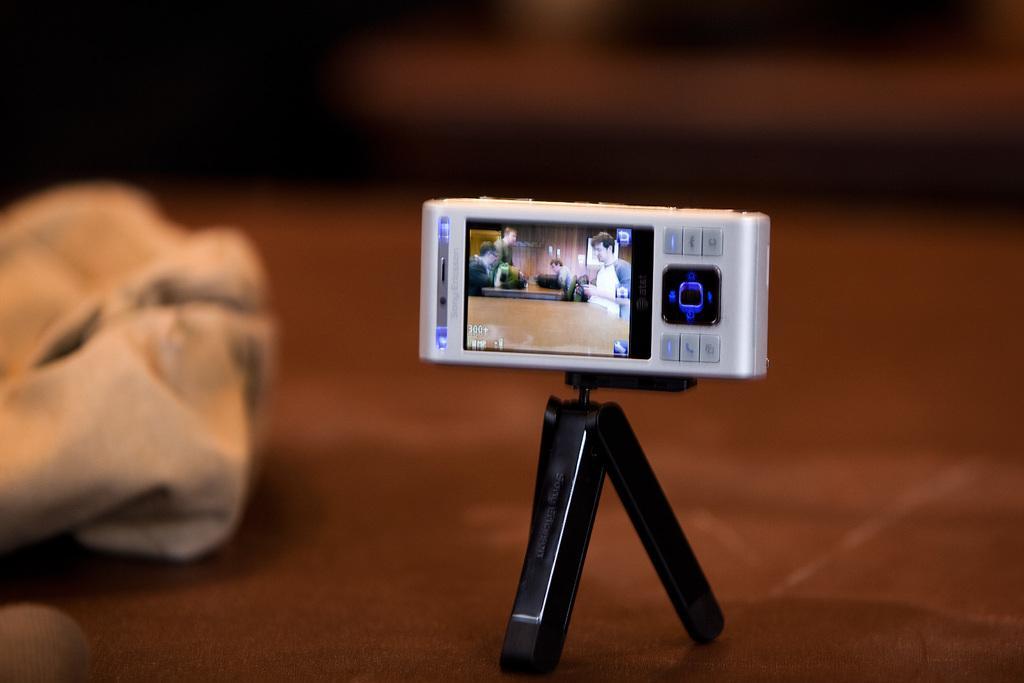Can you describe this image briefly? In this image I can see a mobile phone and a tripod. The background is blurred. 